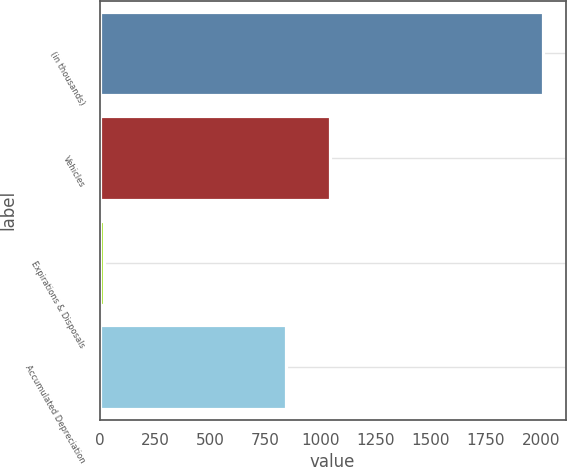<chart> <loc_0><loc_0><loc_500><loc_500><bar_chart><fcel>(in thousands)<fcel>Vehicles<fcel>Expirations & Disposals<fcel>Accumulated Depreciation<nl><fcel>2011<fcel>1042.2<fcel>19<fcel>843<nl></chart> 